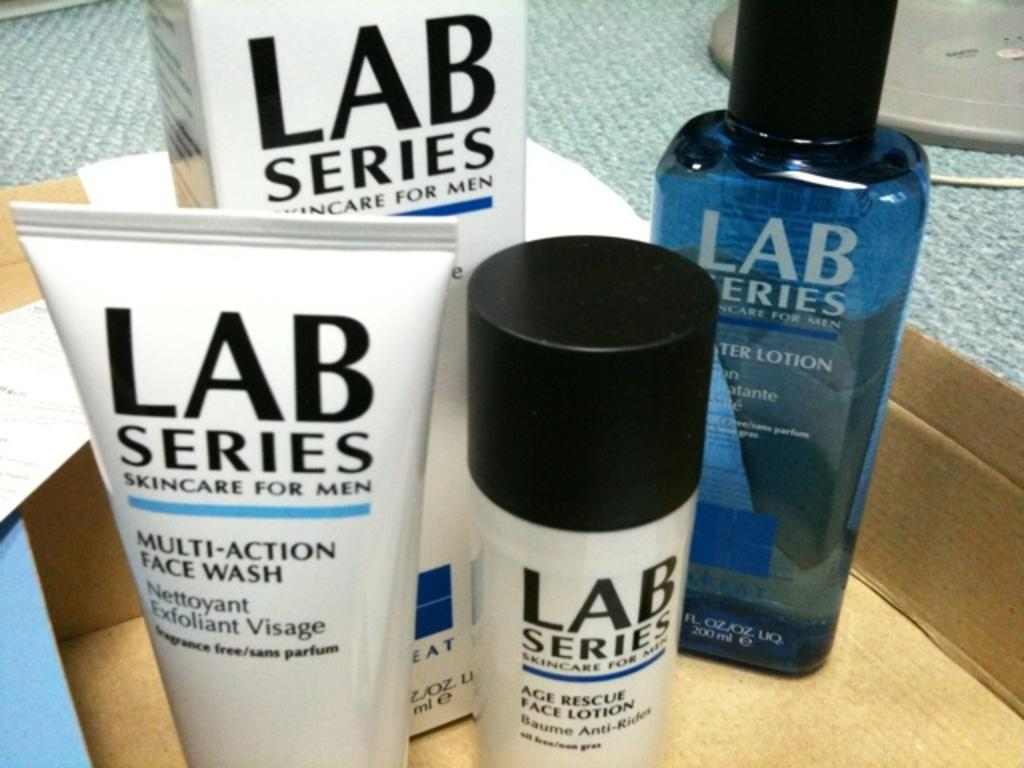<image>
Create a compact narrative representing the image presented. A set of fout Lab Series Skincare for Men products besdie each other in a box. 